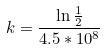Convert formula to latex. <formula><loc_0><loc_0><loc_500><loc_500>k = \frac { \ln \frac { 1 } { 2 } } { 4 . 5 * 1 0 ^ { 8 } }</formula> 